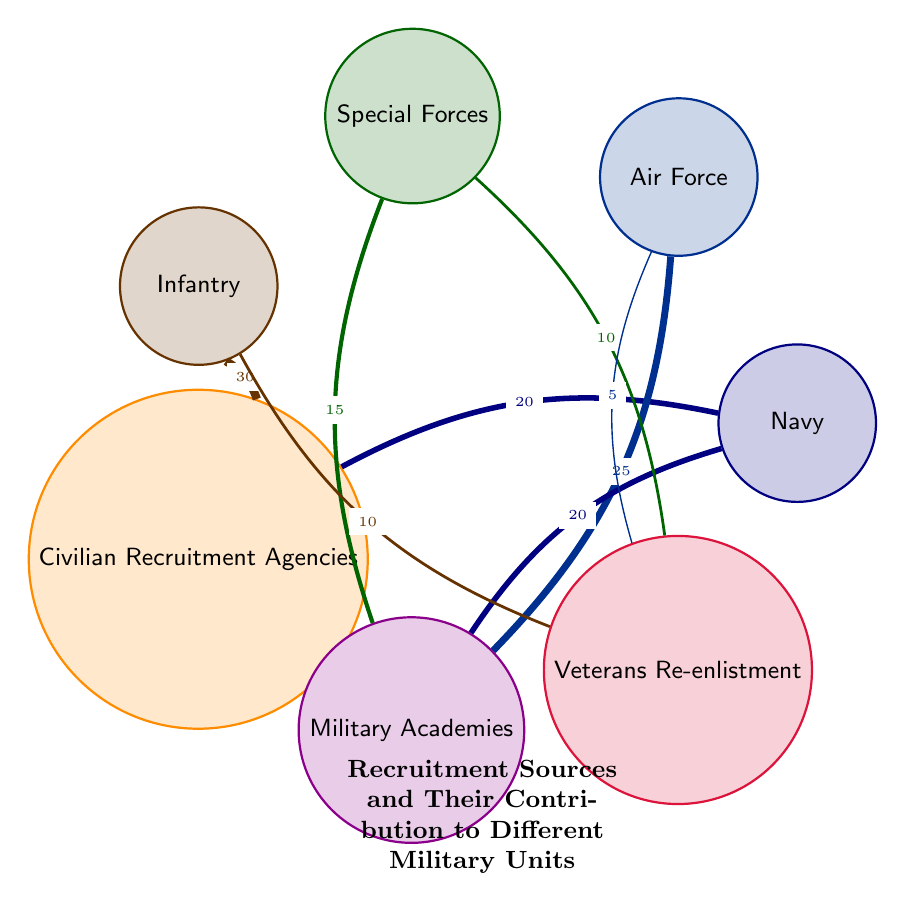What is the total number of recruitment sources represented in the diagram? The diagram shows nodes for three recruitment sources: Civilian Recruitment Agencies, Military Academies, and Veterans Re-enlistment. Counting these sources gives us a total of three.
Answer: 3 Which military unit receives the highest contribution from Civilian Recruitment Agencies? Looking at the links from Civilian Recruitment Agencies, the highest value link is to Infantry with a value of 30, compared to 20 for Navy.
Answer: Infantry What is the contribution of Veterans Re-enlistment to the Air Force? The link from Veterans Re-enlistment to Air Force shows a value of 5. This value is directly listed next to the respective connection in the diagram.
Answer: 5 Which recruitment source has the highest contribution to Special Forces? Analyzing the links, the highest contribution to Special Forces comes from Military Academies with a value of 15, since Veterans Re-enlistment contributes with a value of 10.
Answer: Military Academies What is the sum of the contributions to Infantry from all sources? To find the total contribution to Infantry, we add the values from Civilian Recruitment Agencies (30) and Veterans Re-enlistment (10). Thus, the total is 30 + 10 = 40.
Answer: 40 How many links are there in total from the recruitment sources to military units? Counting all the connections listed in the data, we see there are 8 links. Each link connects a recruitment source to a military unit.
Answer: 8 Which military unit has no links from Veterans Re-enlistment? Looking at the connections from Veterans Re-enlistment, Infantry, Special Forces, and Air Force are linked, while Navy has no connection.
Answer: Navy What is the total value contributed to Navy from all recruitment sources? The links contributing to Navy are from Civilian Recruitment Agencies (20) and Military Academies (20). Adding these values gives 20 + 20 = 40.
Answer: 40 